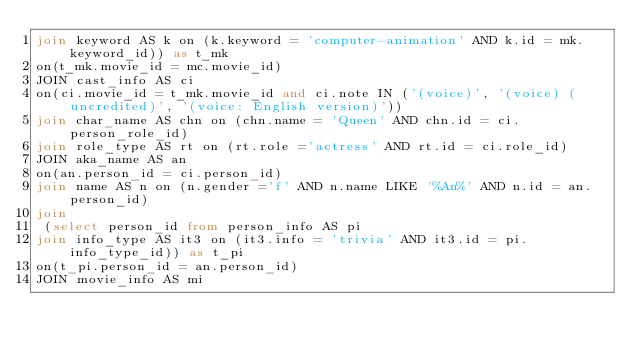Convert code to text. <code><loc_0><loc_0><loc_500><loc_500><_SQL_>join keyword AS k on (k.keyword = 'computer-animation' AND k.id = mk.keyword_id)) as t_mk 
on(t_mk.movie_id = mc.movie_id)
JOIN cast_info AS ci  
on(ci.movie_id = t_mk.movie_id and ci.note IN ('(voice)', '(voice) (uncredited)', '(voice: English version)'))
join char_name AS chn on (chn.name = 'Queen' AND chn.id = ci.person_role_id)
join role_type AS rt on (rt.role ='actress' AND rt.id = ci.role_id)
JOIN aka_name AS an  
on(an.person_id = ci.person_id)
join name AS n on (n.gender ='f' AND n.name LIKE '%An%' AND n.id = an.person_id)
join
 (select person_id from person_info AS pi 
join info_type AS it3 on (it3.info = 'trivia' AND it3.id = pi.info_type_id)) as t_pi 
on(t_pi.person_id = an.person_id)
JOIN movie_info AS mi  </code> 